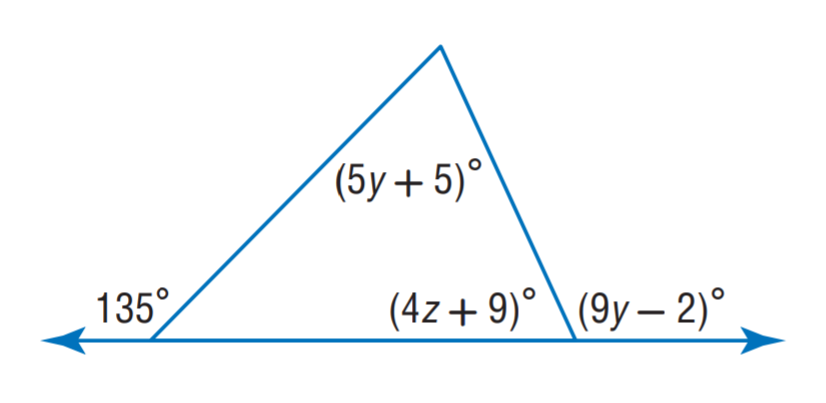Question: Find z.
Choices:
A. 12
B. 13
C. 14
D. 15
Answer with the letter. Answer: C Question: Find y.
Choices:
A. 12
B. 13
C. 14
D. 15
Answer with the letter. Answer: B 